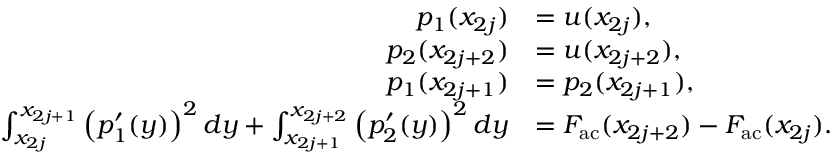Convert formula to latex. <formula><loc_0><loc_0><loc_500><loc_500>\begin{array} { r l } { p _ { 1 } ( x _ { 2 j } ) } & { = u ( x _ { 2 j } ) , } \\ { p _ { 2 } ( x _ { 2 j + 2 } ) } & { = u ( x _ { 2 j + 2 } ) , } \\ { p _ { 1 } ( x _ { 2 j + 1 } ) } & { = p _ { 2 } ( x _ { 2 j + 1 } ) , } \\ { \int _ { x _ { 2 j } } ^ { x _ { 2 j + 1 } } \left ( p _ { 1 } ^ { \prime } ( y ) \right ) ^ { 2 } d y + \int _ { x _ { 2 j + 1 } } ^ { x _ { 2 j + 2 } } \left ( p _ { 2 } ^ { \prime } ( y ) \right ) ^ { 2 } d y } & { = F _ { a c } ( x _ { 2 j + 2 } ) - F _ { a c } ( x _ { 2 j } ) . } \end{array}</formula> 